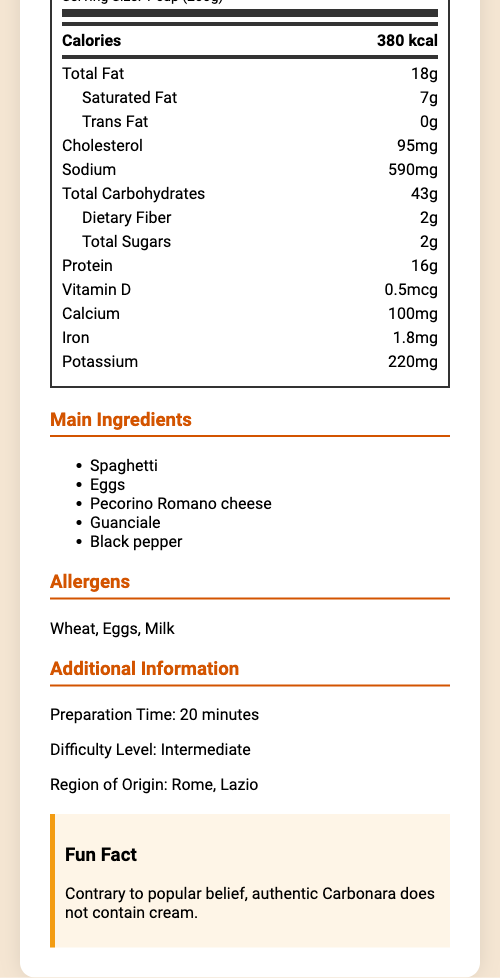what is the name of the dish in Italian? The document specifies "Spaghetti alla Carbonara" as the name of the dish in Italian.
Answer: Spaghetti alla Carbonara how many calories are in one serving? The document states that a serving contains 380 kcal.
Answer: 380 kcal which ingredients are used in the dish? The document lists the main ingredients as Spaghetti, Eggs, Pecorino Romano cheese, Guanciale, and Black pepper.
Answer: Spaghetti, Eggs, Pecorino Romano cheese, Guanciale, Black pepper what is the serving size in English? The document states that the serving size in English is "1 cup (200g)".
Answer: 1 cup (200g) how much cholesterol is in one serving? The document indicates that one serving contains 95 mg of cholesterol.
Answer: 95 mg which region does this dish originate from? A. Florence, Tuscany B. Rome, Lazio C. Naples, Campania D. Milan, Lombardy The document specifies that the dish originates from Rome, Lazio.
Answer: B. Rome, Lazio how much calcium is in one serving? A. 100 mg B. 95 mg C. 200 mg D. 50 mg The document states that one serving contains 100 mg of calcium.
Answer: A. 100 mg does the dish contain any trans fat? The document lists trans fat as 0 g for the dish.
Answer: No is this dish considered easy to prepare? The document categorizes the difficulty level as "Intermediate", indicating it is not easy to prepare.
Answer: No summarize the nutritional information and key details of the dish provided in the document. The summary provides an overview of the nutritional values, main ingredients, allergens, origin, preparation time, and difficulty level from the document.
Answer: Spaghetti alla Carbonara is a traditional Italian pasta dish with a serving size of 1 cup (200g), containing 380 kcal, 18g total fat, 7g saturated fat, 0g trans fat, 95 mg cholesterol, 590 mg sodium, 43g total carbohydrates, 2g dietary fiber, 2g total sugars, 16g protein, 0.5 mcg vitamin D, 100 mg calcium, 1.8 mg iron, and 220 mg potassium. The main ingredients are Spaghetti, Eggs, Pecorino Romano cheese, Guanciale, and Black pepper. It includes allergens such as Wheat, Eggs, and Milk. The dish originates from Rome, Lazio, and requires an intermediate level of skill to prepare, taking about 20 minutes. what is the fun fact mentioned about Carbonara? The document notes that the authentic version of Carbonara does not contain cream.
Answer: Contrary to popular belief, authentic Carbonara does not contain cream. how much vitamin D is in one serving? The document shows that one serving contains 0.5 mcg of vitamin D.
Answer: 0.5 mcg are any vegetables listed in the main ingredients? The main ingredients listed are Spaghetti, Eggs, Pecorino Romano cheese, Guanciale, and Black pepper, with no vegetables mentioned.
Answer: No what is the dietary fiber content in Italian? The dietary fiber content is listed as 2g in both languages.
Answer: 2g how much total carbohydrates are in one serving? The document specifies that there are 43 grams of total carbohydrates in one serving.
Answer: 43 g how long does it take to prepare the dish? The document states the preparation time is 20 minutes.
Answer: 20 minutes which allergens are present in this dish? The allergen information in the document lists Wheat, Eggs, and Milk.
Answer: Wheat, Eggs, Milk what are the total sugars in Italian? The total sugars are listed as 2g in both languages.
Answer: 2g how much iron is in one serving? The document states that one serving contains 1.8 mg of iron.
Answer: 1.8 mg is this dish originally from Venice? The document specifies that the dish originates from Rome, Lazio, not Venice.
Answer: No what is the sodium content in one serving? The document lists the sodium content as 590 mg per serving.
Answer: 590 mg what is the fat content in total? The document states that the total fat content is 18 grams.
Answer: 18g 